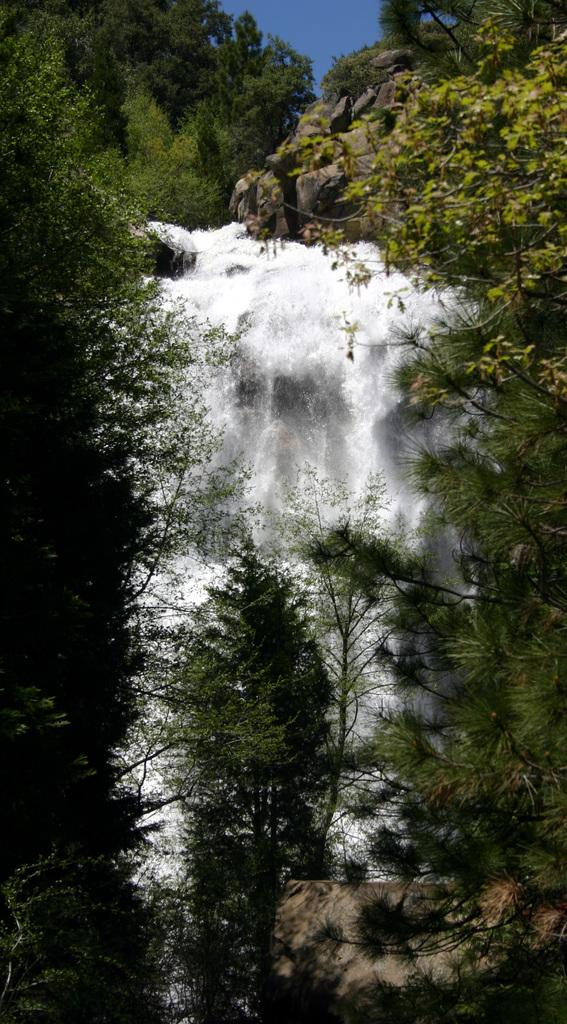What type of vegetation is visible in the front of the image? There are trees in the front of the image. What natural feature is located in the center of the image? There is a waterfall in the center of the image. What type of vegetation is visible in the background of the image? There are trees in the background of the image. What geological feature can be seen in the background of the image? There is a mountain in the background of the image. Can you see any pipes in the image? There are no pipes present in the image. Is there a boot visible in the image? There is no boot present in the image. 